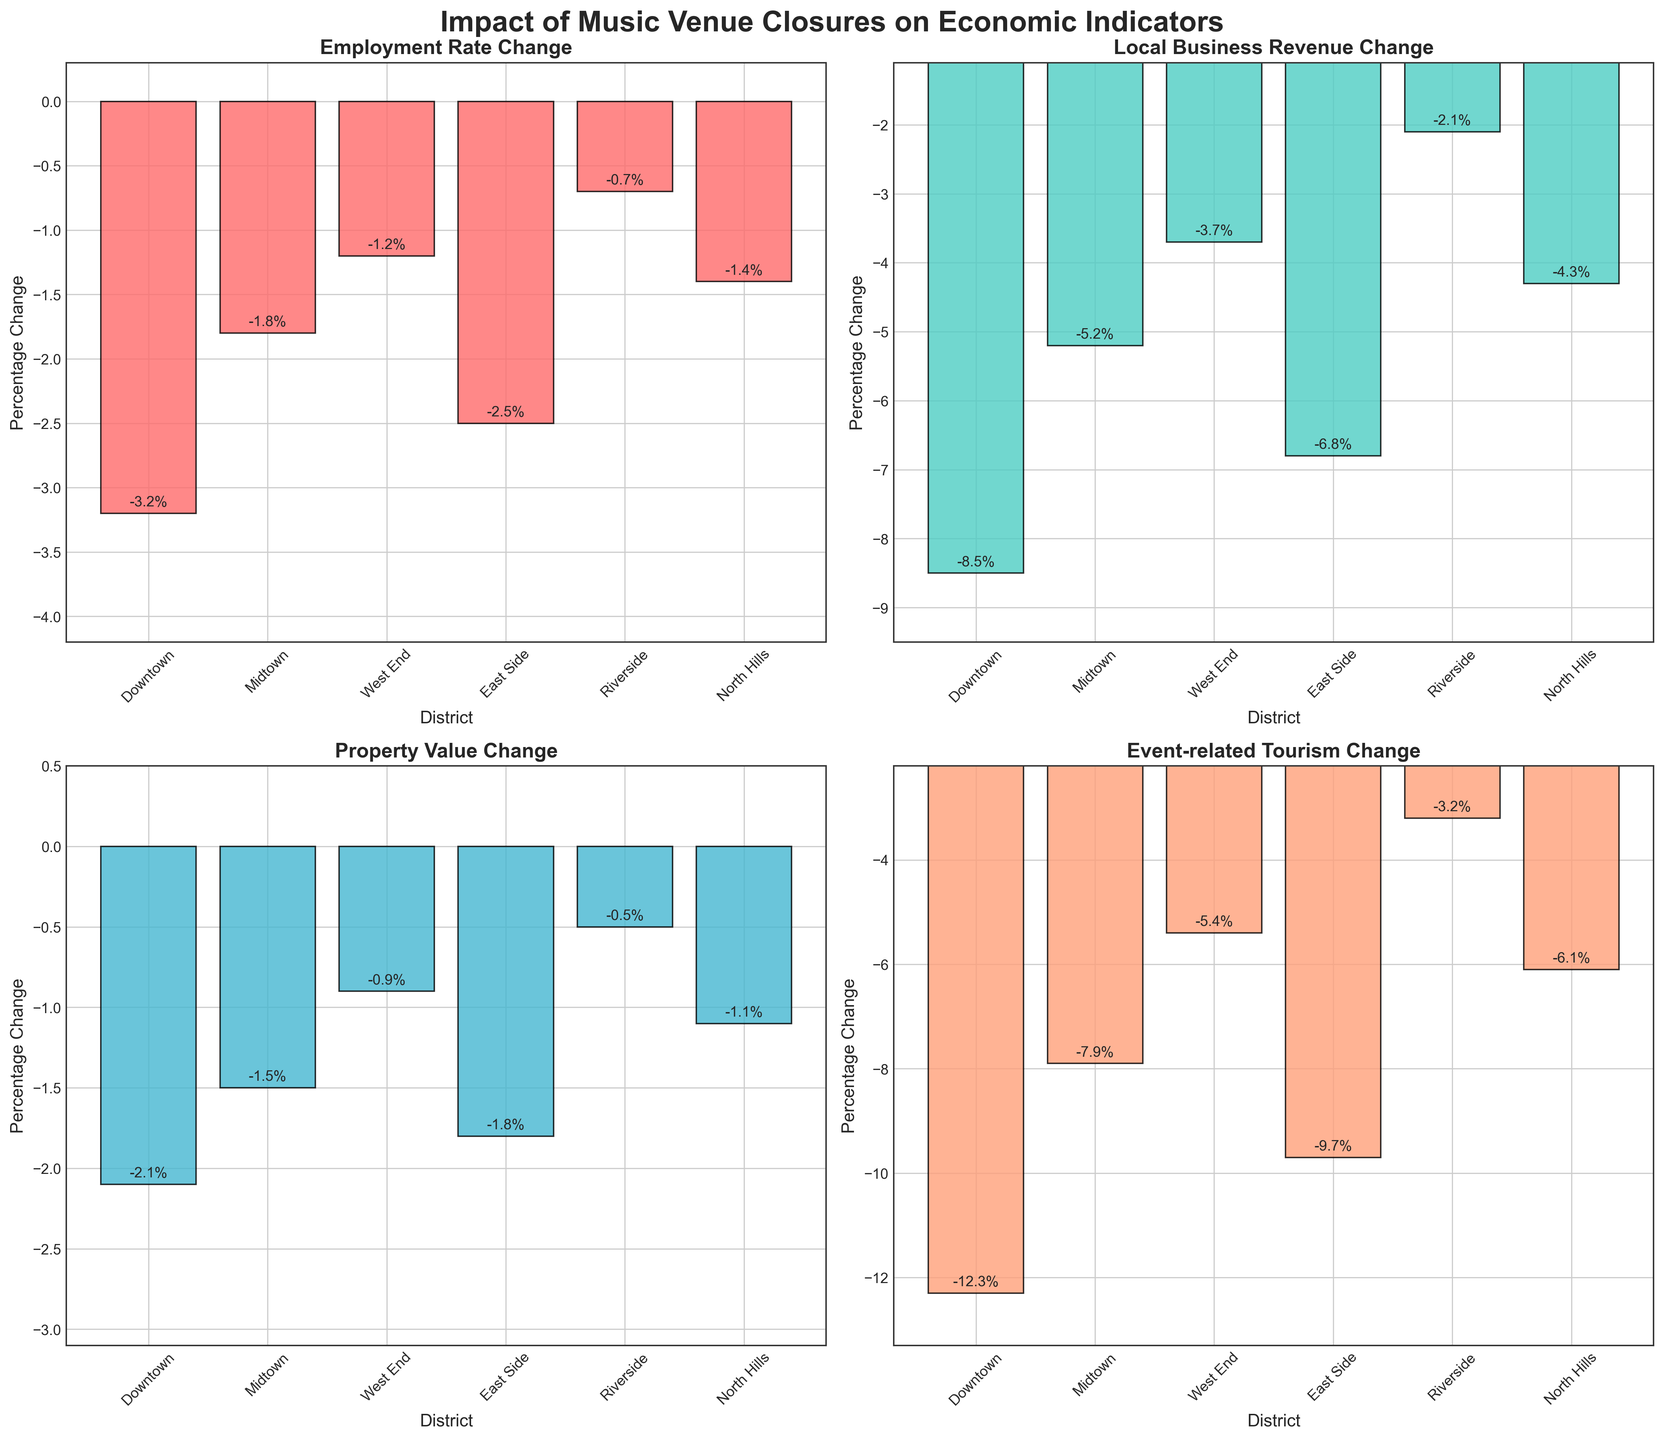What economic indicator shows the largest percentage decline in Downtown? The figure shows multiple economic indicators for each district. For Downtown, we observe the percentages for Employment Rate Change (-3.2%), Local Business Revenue Change (-8.5%), Property Value Change (-2.1%), and Event-related Tourism Change (-12.3%). By comparing these values, the largest decline is in Event-related Tourism Change at -12.3%.
Answer: Event-related Tourism Change Which district experienced the smallest change in Property Value? By examining the percentage changes in Property Value across all districts, we can see that Riverside experienced a -0.5% change, which is the smallest among all the districts. Other values range from -0.9% to -2.1%.
Answer: Riverside What is the average percentage change in Local Business Revenue across all districts? To find the average percentage change in Local Business Revenue, we add all the changes together and divide by the number of districts. The changes are: -8.5%, -5.2%, -3.7%, -6.8%, -2.1%, and -4.3%. Summing these gives: -30.6%. Dividing by the 6 districts, we get -30.6%/6 = -5.1%.
Answer: -5.1% How does the Employment Rate Change in Midtown compare to that in East Side? The Employment Rate Change in Midtown is -1.8%, while in East Side it is -2.5%. Comparing these two, Midtown has a smaller decline in employment rate change than East Side.
Answer: Midtown has a smaller decline Which district shows the greatest improvement (smallest negative change) in Event-related Tourism Change? To find the district with the smallest negative change in Event-related Tourism Change, we compare the values across all districts: Downtown (-12.3%), Midtown (-7.9%), West End (-5.4%), East Side (-9.7%), Riverside (-3.2%), and North Hills (-6.1%). The smallest negative change is -3.2% in Riverside.
Answer: Riverside How many districts experienced more than a 1.5% decline in Employment Rate Change? By examining the Employment Rate Change for all districts, we see the percentage declines: -3.2%, -1.8%, -1.2%, -2.5%, -0.7%, and -1.4%. Comparing these values to -1.5%, four districts (Downtown, Midtown, East Side, and North Hills) experienced more than a 1.5% decline.
Answer: 4 districts What is the total percentage change in Property Value for Downtown and East Side combined? The Property Value Change for Downtown is -2.1%, and for East Side it is -1.8%. Adding these together yields -3.9%.
Answer: -3.9% Among the metrics shown, which one did Riverside experience the least impact on? By observing all percentage changes for Riverside: Employment Rate Change (-0.7%), Local Business Revenue Change (-2.1%), Property Value Change (-0.5%), and Event-related Tourism Change (-3.2%), the least impact was on Property Value Change with -0.5%.
Answer: Property Value Change 